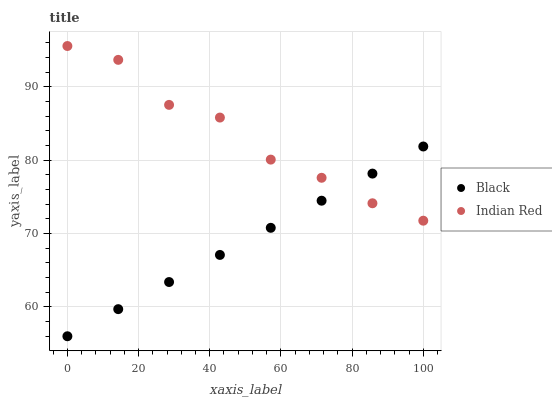Does Black have the minimum area under the curve?
Answer yes or no. Yes. Does Indian Red have the maximum area under the curve?
Answer yes or no. Yes. Does Indian Red have the minimum area under the curve?
Answer yes or no. No. Is Black the smoothest?
Answer yes or no. Yes. Is Indian Red the roughest?
Answer yes or no. Yes. Is Indian Red the smoothest?
Answer yes or no. No. Does Black have the lowest value?
Answer yes or no. Yes. Does Indian Red have the lowest value?
Answer yes or no. No. Does Indian Red have the highest value?
Answer yes or no. Yes. Does Indian Red intersect Black?
Answer yes or no. Yes. Is Indian Red less than Black?
Answer yes or no. No. Is Indian Red greater than Black?
Answer yes or no. No. 